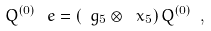Convert formula to latex. <formula><loc_0><loc_0><loc_500><loc_500>Q ^ { ( 0 ) } \, \ e = ( \ g _ { 5 } \otimes \ x _ { 5 } ) \, Q ^ { ( 0 ) } \ ,</formula> 